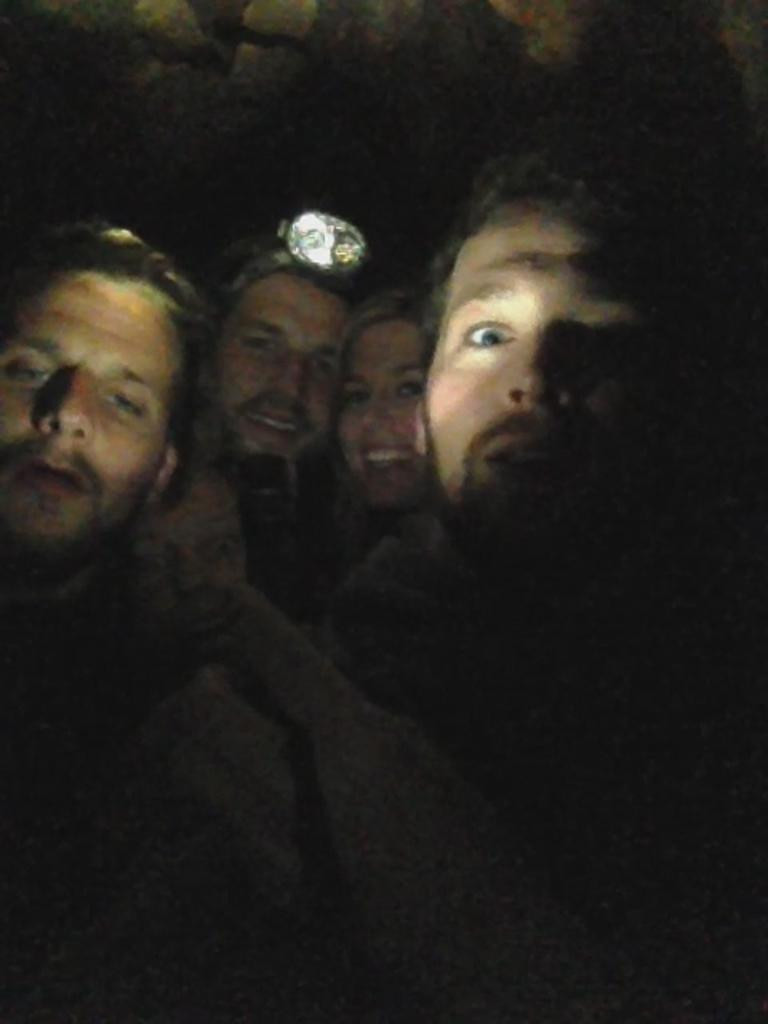How many people are in the image? There is a group of persons in the image. What are the people in the image doing? The group of persons is posing for a selfie. What type of pocket can be seen in the image? There is no pocket visible in the image; it features a group of persons posing for a selfie. What emotion is being expressed by the people in the image? The emotions of the people in the image cannot be determined from the image alone, as facial expressions are not clear enough to make a definitive judgment. 